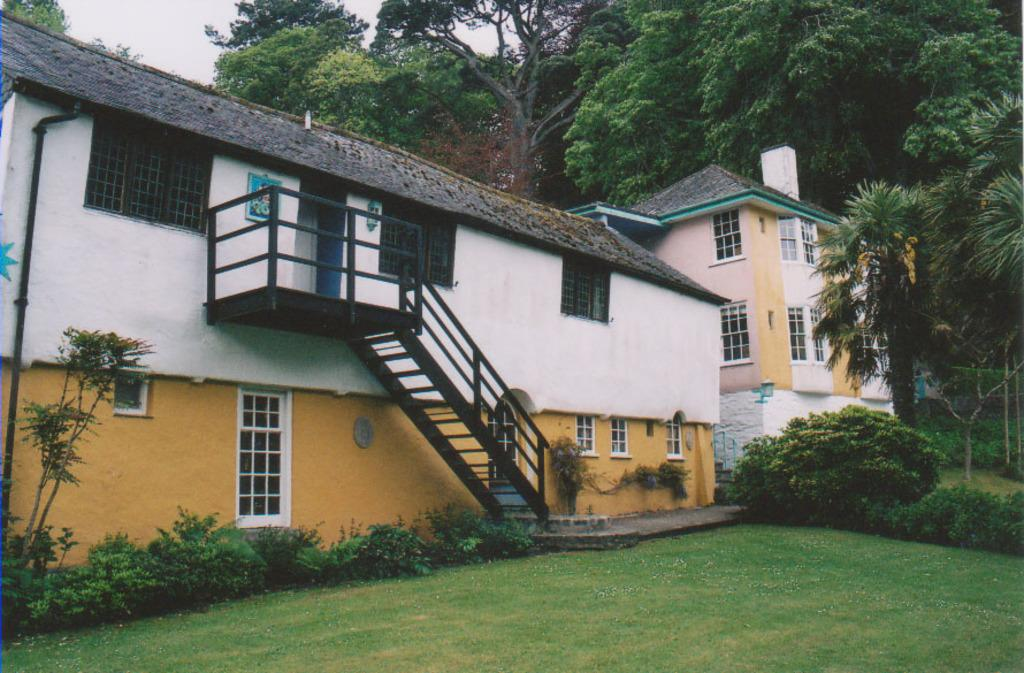What type of surface can be seen in the image? There is ground visible in the image. What type of vegetation is present in the image? There are plants and green trees in the image. What architectural feature can be seen in the image? There are stairs in the image. What type of structures are visible in the image? There are buildings in the image, and their windows can also be seen. What part of the natural environment is visible in the image? The sky is visible in the background of the image. What brand of toothpaste is advertised on the building in the image? There is no toothpaste or advertisement present in the image. What type of love can be seen between the trees in the image? There is no representation of love between the trees in the image; they are simply plants. 